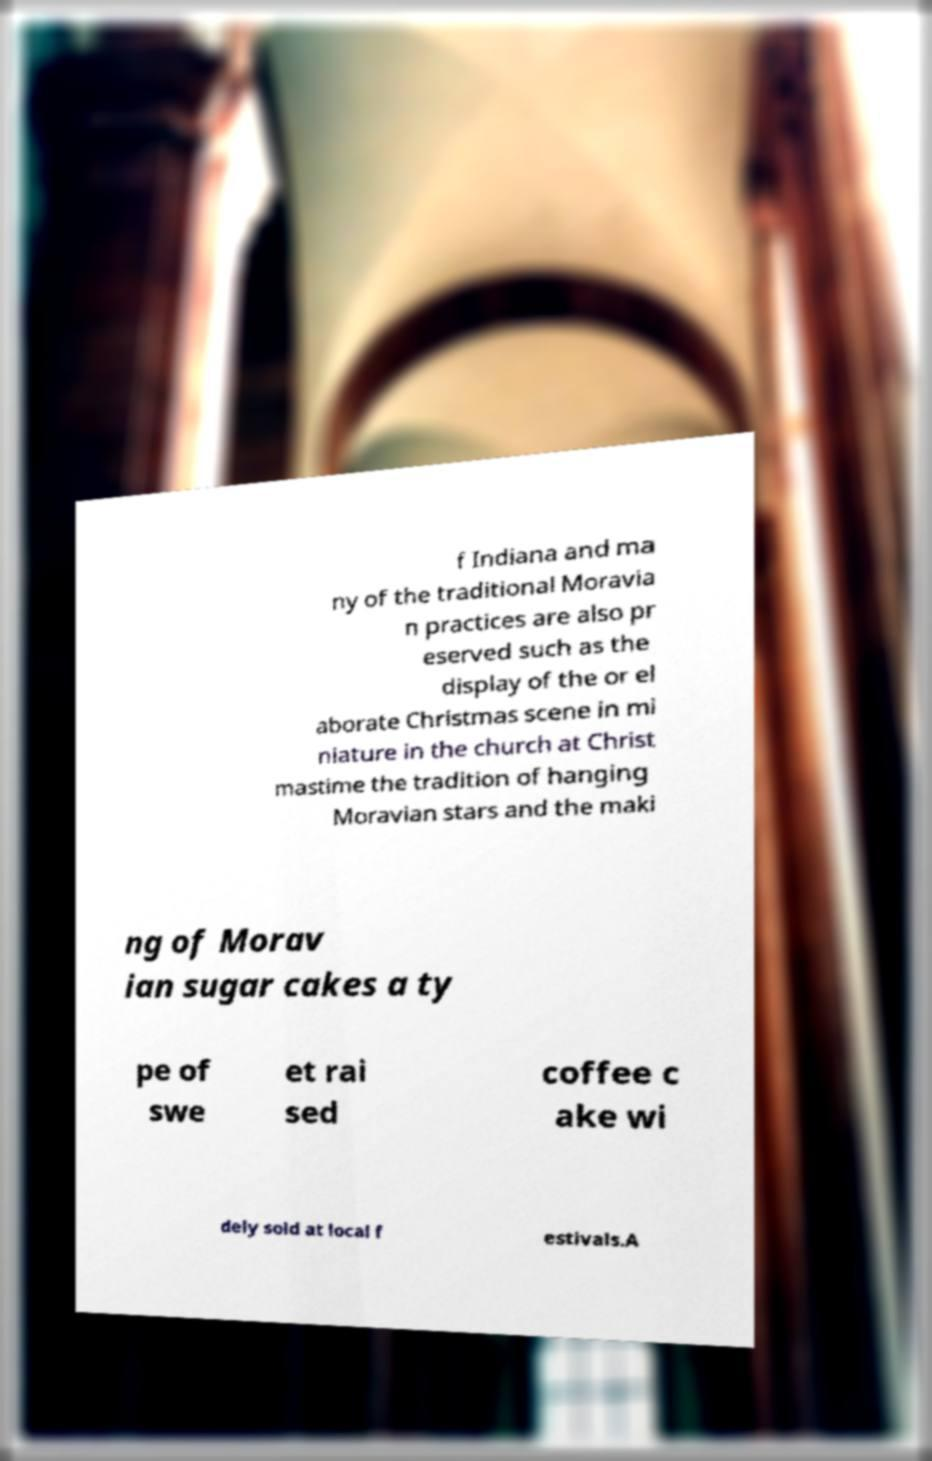What messages or text are displayed in this image? I need them in a readable, typed format. f Indiana and ma ny of the traditional Moravia n practices are also pr eserved such as the display of the or el aborate Christmas scene in mi niature in the church at Christ mastime the tradition of hanging Moravian stars and the maki ng of Morav ian sugar cakes a ty pe of swe et rai sed coffee c ake wi dely sold at local f estivals.A 